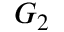<formula> <loc_0><loc_0><loc_500><loc_500>G _ { 2 }</formula> 